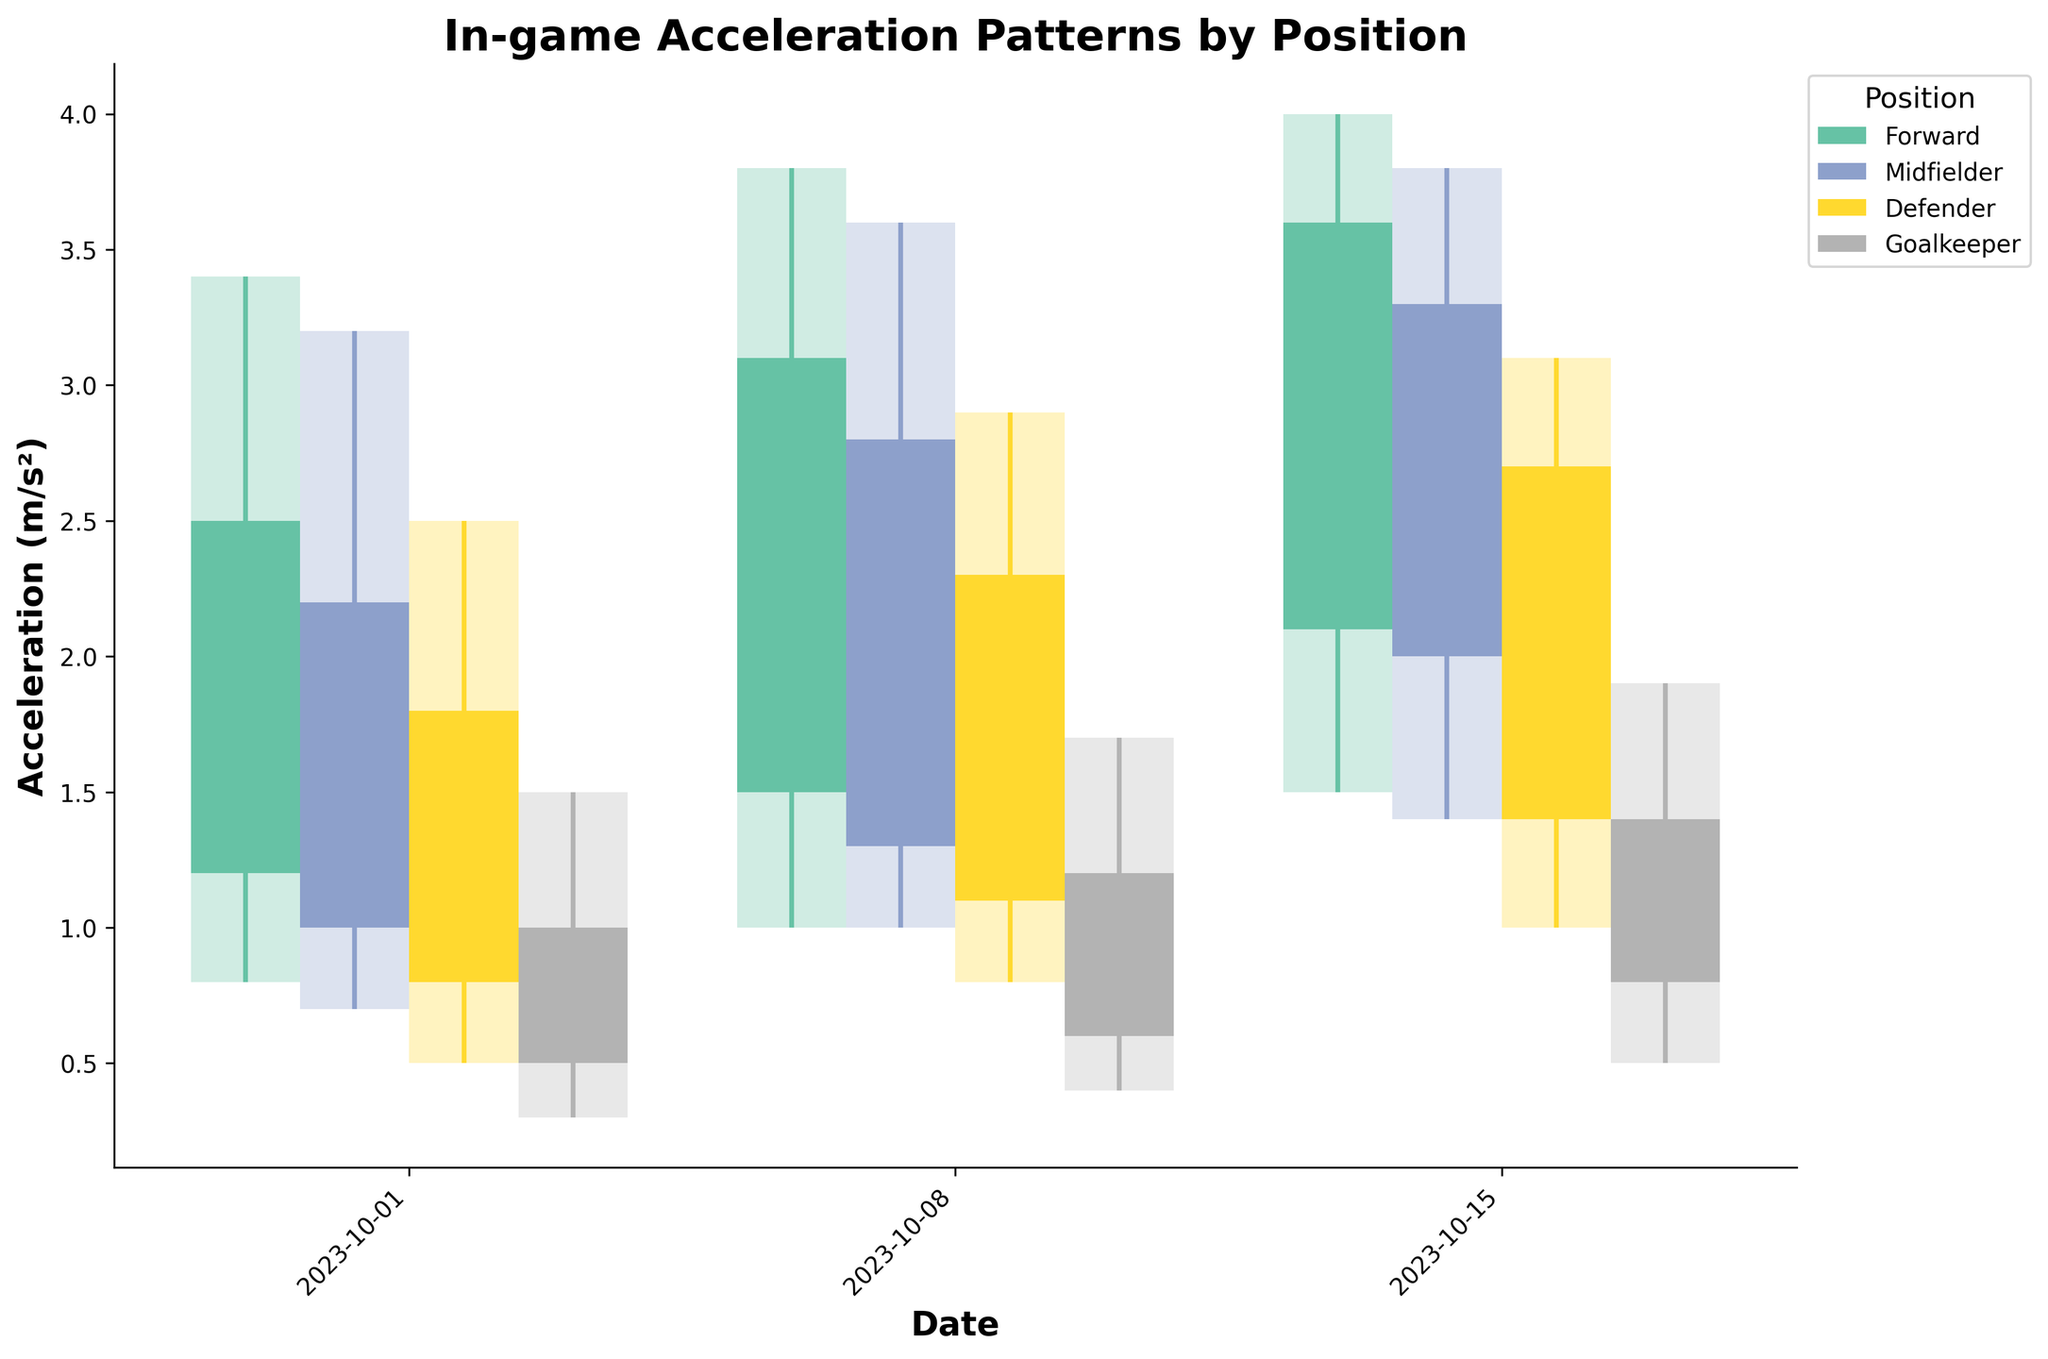What is the title of the figure? The title of the figure is displayed prominently at the top and provides a summary of what the figure represents.
Answer: In-game Acceleration Patterns by Position What are the four playing positions shown in the figure? The legend to the right of the plot lists the playing positions corresponding to different colors.
Answer: Forward, Midfielder, Defender, Goalkeeper Which position has the highest acceleration value recorded, and what is that value? To find this, look at the highest points on the vertical lines for each position. The Forward position has the highest value, which is around 4.0 m/s².
Answer: Forward, 4.0 m/s² How did the acceleration change for Goalkeepers from October 1st to October 15th? Examine the candlestick boxes for October 1st, October 8th, and October 15th specifically for the Goalkeepers to observe the changes in acceleration. Notice the gradual increase from 1.0 m/s² to 1.4 m/s².
Answer: Increased What is the range of acceleration values for Midfielders on October 8th? The range is determined by the high and low points on the vertical line for October 8th. For Midfielders, the high is 3.6 m/s² and the low is 1.0 m/s².
Answer: 1.0 to 3.6 m/s² What is the average closing acceleration for Defenders over the three dates? Sum the closing values for Defenders on each date and divide by the number of dates: (1.8 + 2.3 + 2.7)/3 = 2.27 m/s².
Answer: 2.27 m/s² Which position shows the smallest variability in acceleration on October 15th, and how can it be identified? Variability is indicated by the height of the vertical lines. The Goalkeeper has the shortest vertical line on October 15th, indicating the smallest variability.
Answer: Goalkeeper Compare the average open acceleration values between Forwards and Midfielders over the three dates. Which is higher? Calculate the average open values for both positions: Forwards (1.2 + 1.5 + 2.1)/3 = 1.6, Midfielders (1.0 + 1.3 + 2.0)/3 = 1.43. The Forwards have the higher average.
Answer: Forwards On which date did the Forward position record the lowest closing acceleration and what was the value? Review the closing values for Forward on all dates. The lowest closing acceleration is 2.5 m/s² on October 1st.
Answer: October 1st, 2.5 m/s² 